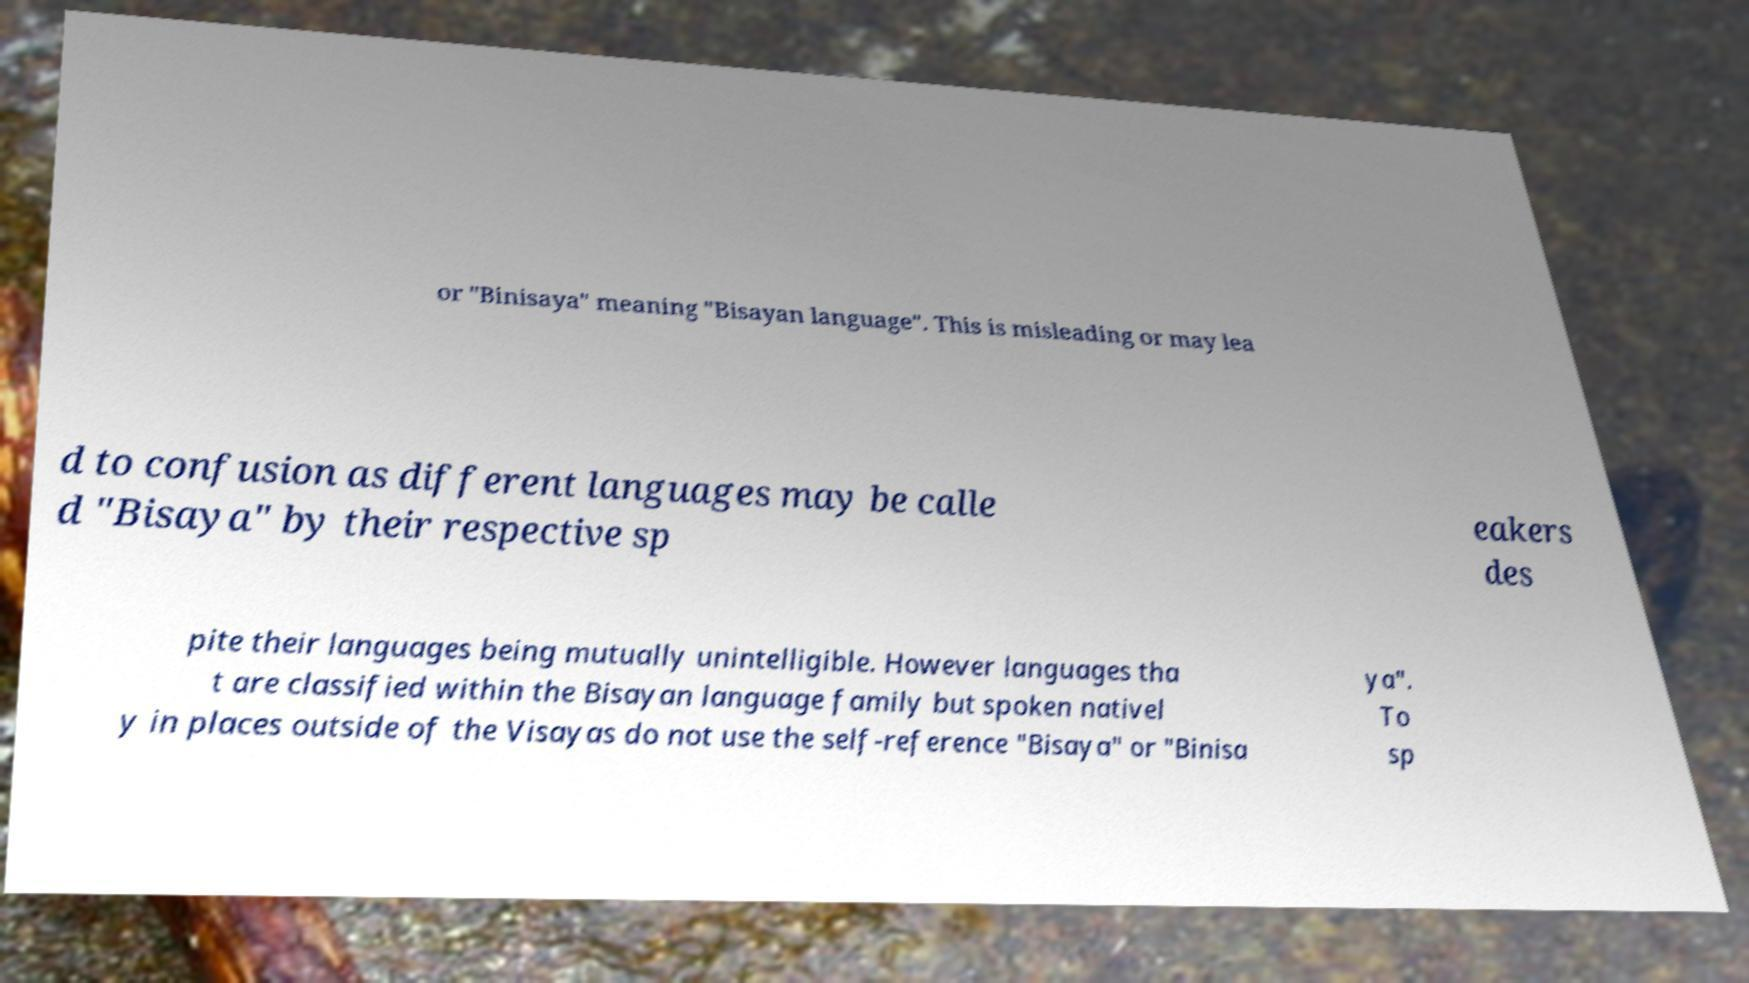Please identify and transcribe the text found in this image. or "Binisaya" meaning "Bisayan language". This is misleading or may lea d to confusion as different languages may be calle d "Bisaya" by their respective sp eakers des pite their languages being mutually unintelligible. However languages tha t are classified within the Bisayan language family but spoken nativel y in places outside of the Visayas do not use the self-reference "Bisaya" or "Binisa ya". To sp 